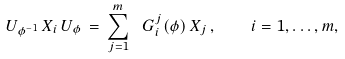<formula> <loc_0><loc_0><loc_500><loc_500>U _ { \phi ^ { - 1 } } \, X _ { i } \, U _ { \phi } \, = \, \sum _ { j = 1 } ^ { m } \ G _ { i } ^ { j } ( \phi ) \, X _ { j } \, , \quad i = 1 , \dots , m ,</formula> 